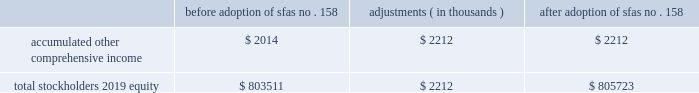Table of contents hologic , inc .
Notes to consolidated financial statements ( continued ) ( in thousands , except per share data ) as of september 26 , 2009 , the company 2019s financial assets that are re-measured at fair value on a recurring basis consisted of $ 313 in money market mutual funds that are classified as cash and cash equivalents in the consolidated balance sheets .
As there are no withdrawal restrictions , they are classified within level 1 of the fair value hierarchy and are valued using quoted market prices for identical assets .
The company holds certain minority cost-method equity investments in non-publicly traded securities aggregating $ 7585 and $ 9278 at september 26 , 2009 and september 27 , 2008 , respectively , which are included in other long-term assets on the company 2019s consolidated balance sheets .
These investments are generally carried at cost .
As the inputs utilized for the company 2019s periodic impairment assessment are not based on observable market data , these cost method investments are classified within level 3 of the fair value hierarchy on a non-recurring basis .
To determine the fair value of these investments , the company uses all available financial information related to the entities , including information based on recent or pending third-party equity investments in these entities .
In certain instances , a cost method investment 2019s fair value is not estimated as there are no identified events or changes in circumstances that may have a significant adverse effect on the fair value of the investment and to do so would be impractical .
During fiscal 2009 , the company recorded other-than-temporary impairment charges totaling $ 2243 related to two of its cost method investments to adjust their carrying amounts to fair value .
Pension and other employee benefits the company has certain defined benefit pension plans covering the employees of its aeg german subsidiary ( the 201cpension benefits 201d ) .
As of september 29 , 2007 , the company adopted sfas no .
158 , employers 2019 accounting for defined benefit pension and other postretirement plans , an amendment of fasb statements no .
87 , 88 , 106 and 132 ( r ) ( codified primarily in asc 715 , defined benefit plans ) using a prospective approach .
The adoption of this standard did not impact the company 2019s compliance with its debt covenants under its credit agreements , cash position or results of operations .
The table summarizes the incremental effect of adopting this standard on individual line items in the consolidated balance sheet as of september 29 , 2007 : before adoption of sfas no .
158 adjustments ( in thousands ) adoption of sfas no .
158 .
As of september 26 , 2009 and september 27 , 2008 , the company 2019s pension liability is $ 6736 and $ 7323 , respectively , which is primarily recorded as a component of long-term liabilities in the consolidated balance sheets .
Under german law , there are no rules governing investment or statutory supervision of the pension plan .
As such , there is no minimum funding requirement imposed on employers .
Pension benefits are safeguarded by the pension guaranty fund , a form of compulsory reinsurance that guarantees an employee will receive vested pension benefits in the event of insolvency .
Source : hologic inc , 10-k , november 24 , 2009 powered by morningstar ae document research 2120 the information contained herein may not be copied , adapted or distributed and is not warranted to be accurate , complete or timely .
The user assumes all risks for any damages or losses arising from any use of this information , except to the extent such damages or losses cannot be limited or excluded by applicable law .
Past financial performance is no guarantee of future results. .
What is the percentage change in total stockholders 2019 equity due to adoption of sfas no . 158? 
Computations: (2212 / 803511)
Answer: 0.00275. 